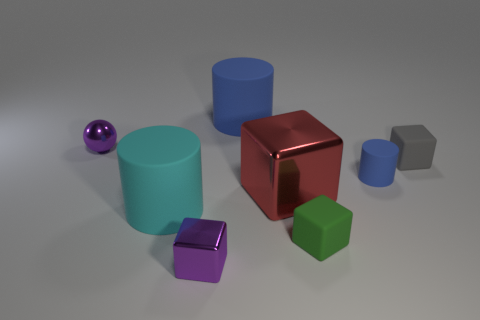Subtract all big cylinders. How many cylinders are left? 1 Add 1 tiny yellow cylinders. How many objects exist? 9 Subtract all blue cylinders. How many cylinders are left? 1 Subtract all balls. How many objects are left? 7 Subtract 1 spheres. How many spheres are left? 0 Subtract all purple cylinders. Subtract all brown blocks. How many cylinders are left? 3 Add 6 gray cubes. How many gray cubes are left? 7 Add 8 big purple matte things. How many big purple matte things exist? 8 Subtract 0 blue cubes. How many objects are left? 8 Subtract all red spheres. How many blue cylinders are left? 2 